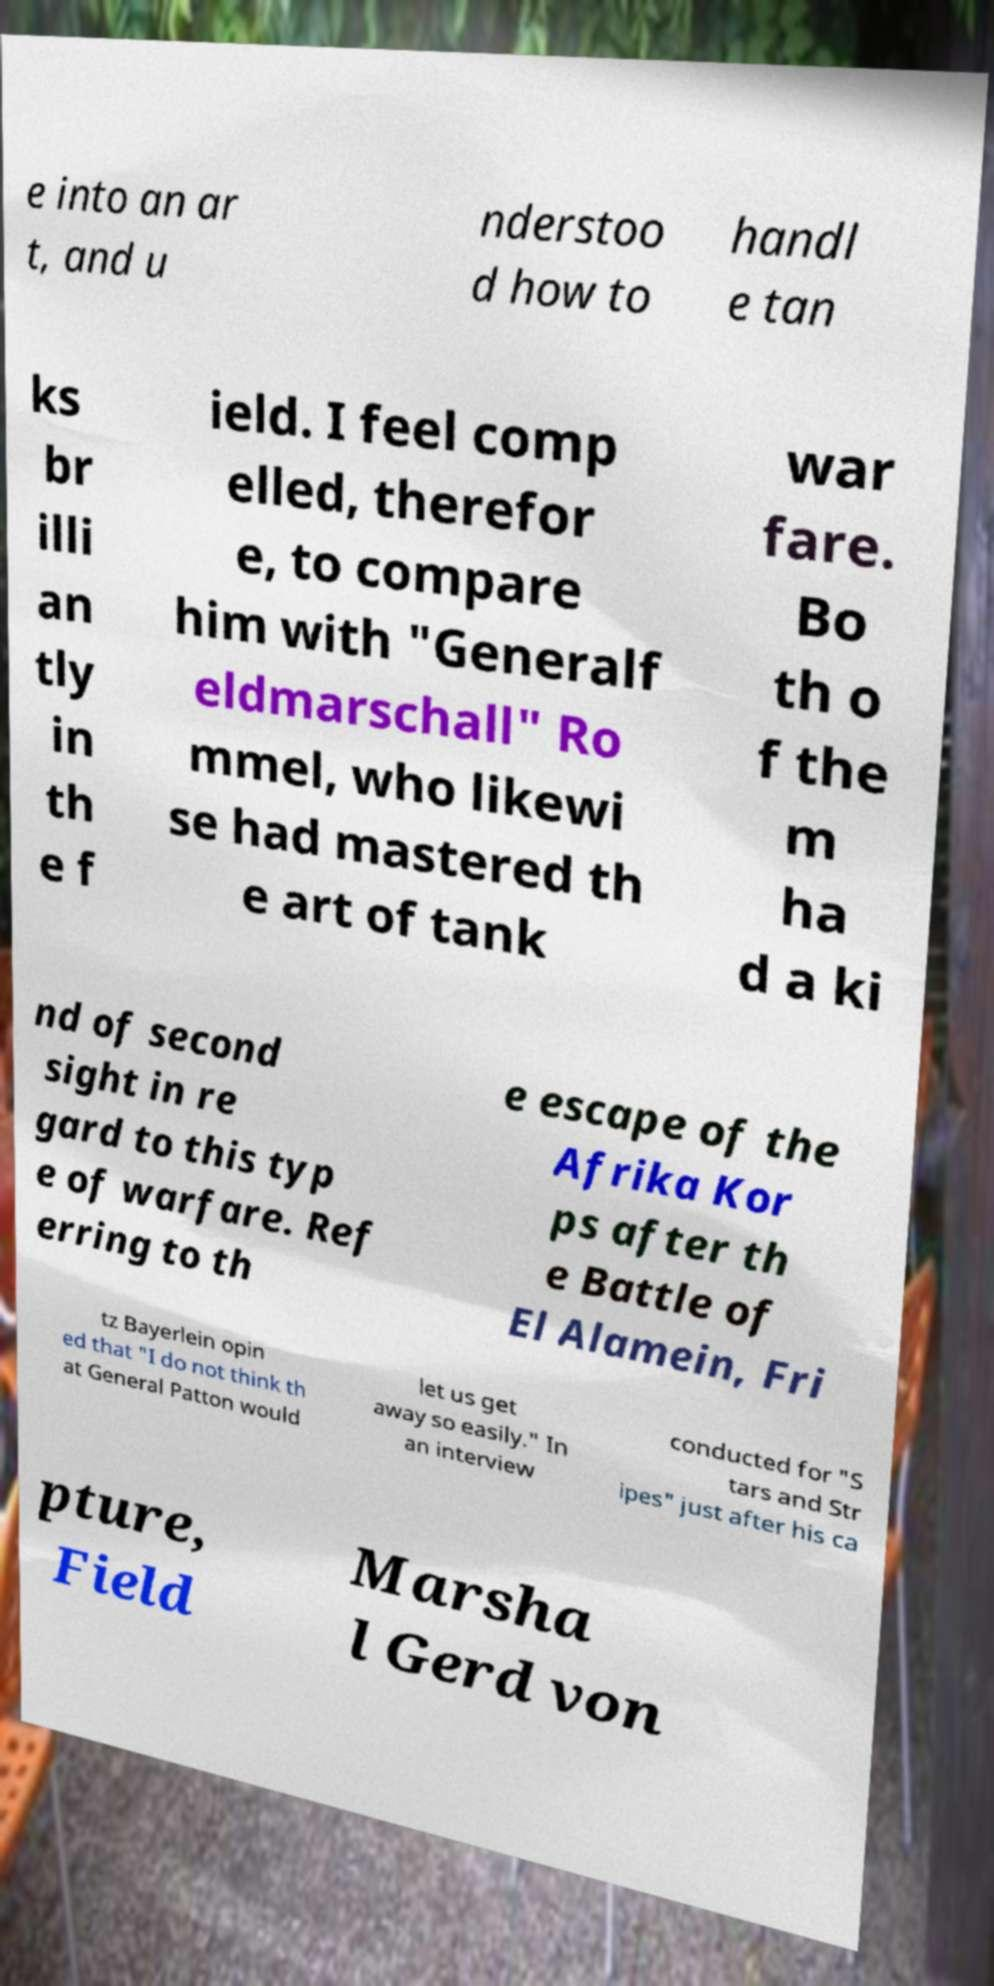Could you extract and type out the text from this image? e into an ar t, and u nderstoo d how to handl e tan ks br illi an tly in th e f ield. I feel comp elled, therefor e, to compare him with "Generalf eldmarschall" Ro mmel, who likewi se had mastered th e art of tank war fare. Bo th o f the m ha d a ki nd of second sight in re gard to this typ e of warfare. Ref erring to th e escape of the Afrika Kor ps after th e Battle of El Alamein, Fri tz Bayerlein opin ed that "I do not think th at General Patton would let us get away so easily." In an interview conducted for "S tars and Str ipes" just after his ca pture, Field Marsha l Gerd von 